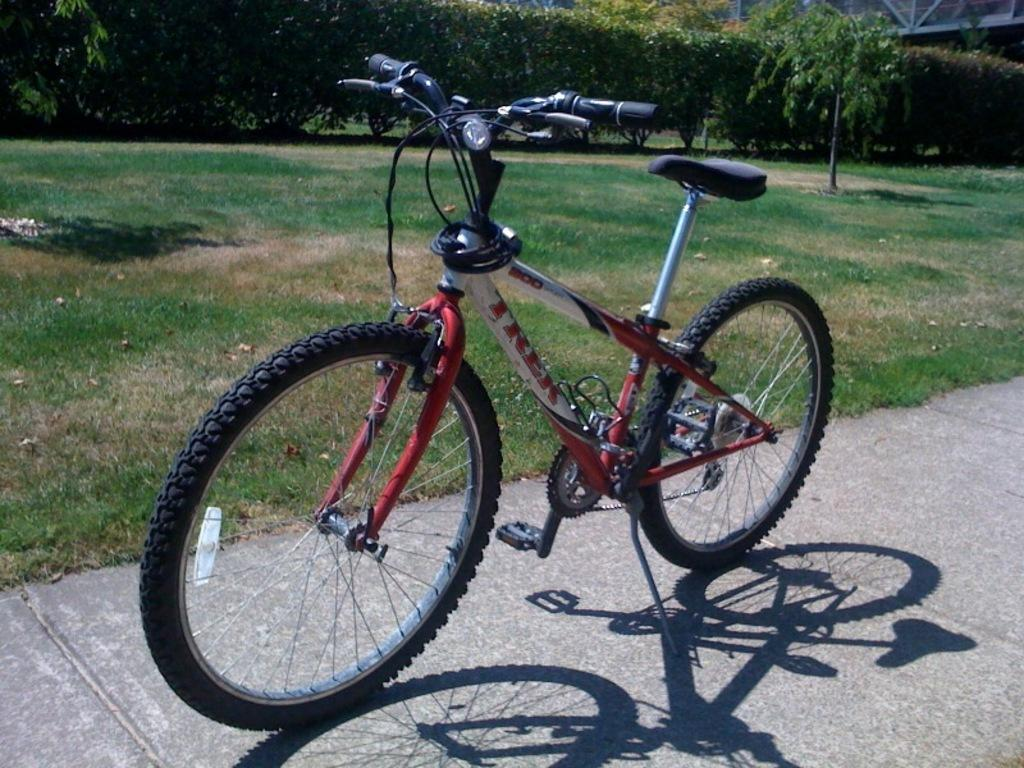What is located on the sidewalk in the image? There is a bicycle on the sidewalk. What type of vegetation can be seen in the image? There are trees visible in the image. How much dirt is visible in the pocket of the person in the image? There is no person visible in the image, and therefore no pocket or dirt can be observed. 